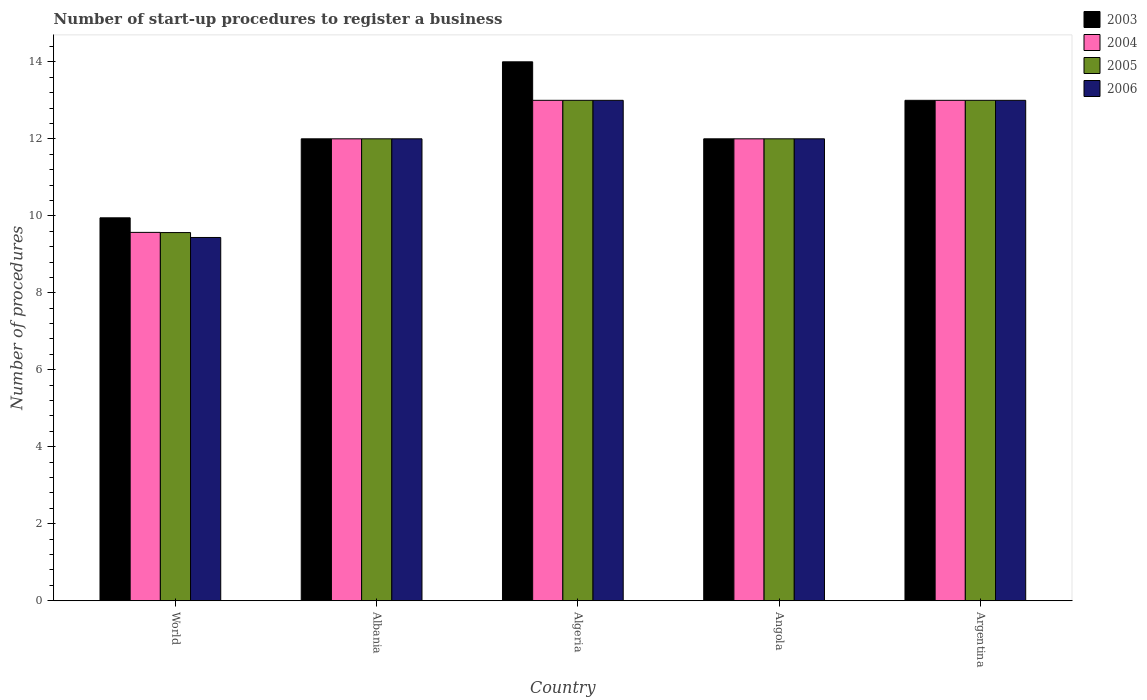What is the label of the 5th group of bars from the left?
Your answer should be compact. Argentina. In how many cases, is the number of bars for a given country not equal to the number of legend labels?
Give a very brief answer. 0. Across all countries, what is the maximum number of procedures required to register a business in 2004?
Offer a terse response. 13. Across all countries, what is the minimum number of procedures required to register a business in 2005?
Keep it short and to the point. 9.56. In which country was the number of procedures required to register a business in 2005 maximum?
Make the answer very short. Algeria. What is the total number of procedures required to register a business in 2003 in the graph?
Give a very brief answer. 60.95. What is the average number of procedures required to register a business in 2005 per country?
Provide a short and direct response. 11.91. What is the ratio of the number of procedures required to register a business in 2005 in Algeria to that in World?
Your answer should be compact. 1.36. Is the number of procedures required to register a business in 2005 in Albania less than that in Algeria?
Your answer should be very brief. Yes. Is the difference between the number of procedures required to register a business in 2006 in Algeria and Angola greater than the difference between the number of procedures required to register a business in 2003 in Algeria and Angola?
Your answer should be compact. No. What is the difference between the highest and the second highest number of procedures required to register a business in 2003?
Ensure brevity in your answer.  -1. What is the difference between the highest and the lowest number of procedures required to register a business in 2004?
Your answer should be compact. 3.43. In how many countries, is the number of procedures required to register a business in 2006 greater than the average number of procedures required to register a business in 2006 taken over all countries?
Offer a terse response. 4. What does the 3rd bar from the left in World represents?
Provide a succinct answer. 2005. What does the 4th bar from the right in Albania represents?
Give a very brief answer. 2003. Are all the bars in the graph horizontal?
Your answer should be compact. No. How many countries are there in the graph?
Your answer should be compact. 5. Are the values on the major ticks of Y-axis written in scientific E-notation?
Offer a very short reply. No. Where does the legend appear in the graph?
Ensure brevity in your answer.  Top right. What is the title of the graph?
Offer a very short reply. Number of start-up procedures to register a business. What is the label or title of the X-axis?
Offer a terse response. Country. What is the label or title of the Y-axis?
Make the answer very short. Number of procedures. What is the Number of procedures of 2003 in World?
Offer a terse response. 9.95. What is the Number of procedures in 2004 in World?
Offer a terse response. 9.57. What is the Number of procedures of 2005 in World?
Provide a succinct answer. 9.56. What is the Number of procedures in 2006 in World?
Give a very brief answer. 9.44. What is the Number of procedures of 2005 in Albania?
Your answer should be very brief. 12. What is the Number of procedures of 2005 in Algeria?
Provide a succinct answer. 13. What is the Number of procedures in 2003 in Angola?
Keep it short and to the point. 12. What is the Number of procedures of 2004 in Angola?
Give a very brief answer. 12. What is the Number of procedures of 2004 in Argentina?
Your answer should be compact. 13. Across all countries, what is the maximum Number of procedures in 2005?
Give a very brief answer. 13. Across all countries, what is the minimum Number of procedures of 2003?
Make the answer very short. 9.95. Across all countries, what is the minimum Number of procedures in 2004?
Your answer should be compact. 9.57. Across all countries, what is the minimum Number of procedures in 2005?
Ensure brevity in your answer.  9.56. Across all countries, what is the minimum Number of procedures in 2006?
Provide a short and direct response. 9.44. What is the total Number of procedures in 2003 in the graph?
Your response must be concise. 60.95. What is the total Number of procedures of 2004 in the graph?
Your answer should be very brief. 59.57. What is the total Number of procedures of 2005 in the graph?
Keep it short and to the point. 59.56. What is the total Number of procedures of 2006 in the graph?
Offer a terse response. 59.44. What is the difference between the Number of procedures of 2003 in World and that in Albania?
Offer a very short reply. -2.05. What is the difference between the Number of procedures of 2004 in World and that in Albania?
Provide a short and direct response. -2.43. What is the difference between the Number of procedures of 2005 in World and that in Albania?
Ensure brevity in your answer.  -2.44. What is the difference between the Number of procedures in 2006 in World and that in Albania?
Your answer should be very brief. -2.56. What is the difference between the Number of procedures of 2003 in World and that in Algeria?
Ensure brevity in your answer.  -4.05. What is the difference between the Number of procedures in 2004 in World and that in Algeria?
Make the answer very short. -3.43. What is the difference between the Number of procedures of 2005 in World and that in Algeria?
Ensure brevity in your answer.  -3.44. What is the difference between the Number of procedures in 2006 in World and that in Algeria?
Keep it short and to the point. -3.56. What is the difference between the Number of procedures in 2003 in World and that in Angola?
Provide a short and direct response. -2.05. What is the difference between the Number of procedures in 2004 in World and that in Angola?
Give a very brief answer. -2.43. What is the difference between the Number of procedures of 2005 in World and that in Angola?
Your response must be concise. -2.44. What is the difference between the Number of procedures of 2006 in World and that in Angola?
Your answer should be compact. -2.56. What is the difference between the Number of procedures of 2003 in World and that in Argentina?
Your answer should be very brief. -3.05. What is the difference between the Number of procedures in 2004 in World and that in Argentina?
Provide a succinct answer. -3.43. What is the difference between the Number of procedures of 2005 in World and that in Argentina?
Your answer should be compact. -3.44. What is the difference between the Number of procedures in 2006 in World and that in Argentina?
Your answer should be compact. -3.56. What is the difference between the Number of procedures of 2005 in Albania and that in Algeria?
Your answer should be very brief. -1. What is the difference between the Number of procedures of 2003 in Albania and that in Angola?
Offer a terse response. 0. What is the difference between the Number of procedures in 2004 in Albania and that in Angola?
Provide a succinct answer. 0. What is the difference between the Number of procedures in 2006 in Albania and that in Angola?
Your answer should be very brief. 0. What is the difference between the Number of procedures in 2004 in Algeria and that in Angola?
Your answer should be very brief. 1. What is the difference between the Number of procedures in 2004 in Algeria and that in Argentina?
Offer a very short reply. 0. What is the difference between the Number of procedures in 2005 in Algeria and that in Argentina?
Provide a short and direct response. 0. What is the difference between the Number of procedures in 2003 in Angola and that in Argentina?
Offer a very short reply. -1. What is the difference between the Number of procedures of 2006 in Angola and that in Argentina?
Provide a succinct answer. -1. What is the difference between the Number of procedures in 2003 in World and the Number of procedures in 2004 in Albania?
Provide a succinct answer. -2.05. What is the difference between the Number of procedures of 2003 in World and the Number of procedures of 2005 in Albania?
Offer a terse response. -2.05. What is the difference between the Number of procedures of 2003 in World and the Number of procedures of 2006 in Albania?
Keep it short and to the point. -2.05. What is the difference between the Number of procedures in 2004 in World and the Number of procedures in 2005 in Albania?
Your answer should be very brief. -2.43. What is the difference between the Number of procedures of 2004 in World and the Number of procedures of 2006 in Albania?
Offer a terse response. -2.43. What is the difference between the Number of procedures of 2005 in World and the Number of procedures of 2006 in Albania?
Give a very brief answer. -2.44. What is the difference between the Number of procedures of 2003 in World and the Number of procedures of 2004 in Algeria?
Provide a succinct answer. -3.05. What is the difference between the Number of procedures in 2003 in World and the Number of procedures in 2005 in Algeria?
Provide a short and direct response. -3.05. What is the difference between the Number of procedures of 2003 in World and the Number of procedures of 2006 in Algeria?
Your answer should be compact. -3.05. What is the difference between the Number of procedures in 2004 in World and the Number of procedures in 2005 in Algeria?
Your answer should be compact. -3.43. What is the difference between the Number of procedures in 2004 in World and the Number of procedures in 2006 in Algeria?
Your response must be concise. -3.43. What is the difference between the Number of procedures in 2005 in World and the Number of procedures in 2006 in Algeria?
Make the answer very short. -3.44. What is the difference between the Number of procedures of 2003 in World and the Number of procedures of 2004 in Angola?
Ensure brevity in your answer.  -2.05. What is the difference between the Number of procedures of 2003 in World and the Number of procedures of 2005 in Angola?
Give a very brief answer. -2.05. What is the difference between the Number of procedures in 2003 in World and the Number of procedures in 2006 in Angola?
Keep it short and to the point. -2.05. What is the difference between the Number of procedures of 2004 in World and the Number of procedures of 2005 in Angola?
Ensure brevity in your answer.  -2.43. What is the difference between the Number of procedures of 2004 in World and the Number of procedures of 2006 in Angola?
Keep it short and to the point. -2.43. What is the difference between the Number of procedures of 2005 in World and the Number of procedures of 2006 in Angola?
Offer a terse response. -2.44. What is the difference between the Number of procedures of 2003 in World and the Number of procedures of 2004 in Argentina?
Give a very brief answer. -3.05. What is the difference between the Number of procedures in 2003 in World and the Number of procedures in 2005 in Argentina?
Offer a very short reply. -3.05. What is the difference between the Number of procedures of 2003 in World and the Number of procedures of 2006 in Argentina?
Offer a very short reply. -3.05. What is the difference between the Number of procedures of 2004 in World and the Number of procedures of 2005 in Argentina?
Give a very brief answer. -3.43. What is the difference between the Number of procedures of 2004 in World and the Number of procedures of 2006 in Argentina?
Give a very brief answer. -3.43. What is the difference between the Number of procedures in 2005 in World and the Number of procedures in 2006 in Argentina?
Make the answer very short. -3.44. What is the difference between the Number of procedures of 2003 in Albania and the Number of procedures of 2005 in Algeria?
Your answer should be very brief. -1. What is the difference between the Number of procedures in 2004 in Albania and the Number of procedures in 2005 in Algeria?
Ensure brevity in your answer.  -1. What is the difference between the Number of procedures of 2004 in Albania and the Number of procedures of 2006 in Algeria?
Your answer should be compact. -1. What is the difference between the Number of procedures in 2005 in Albania and the Number of procedures in 2006 in Algeria?
Ensure brevity in your answer.  -1. What is the difference between the Number of procedures in 2003 in Albania and the Number of procedures in 2004 in Angola?
Your answer should be very brief. 0. What is the difference between the Number of procedures in 2004 in Albania and the Number of procedures in 2006 in Angola?
Ensure brevity in your answer.  0. What is the difference between the Number of procedures of 2003 in Albania and the Number of procedures of 2005 in Argentina?
Your answer should be very brief. -1. What is the difference between the Number of procedures of 2003 in Algeria and the Number of procedures of 2004 in Angola?
Provide a succinct answer. 2. What is the difference between the Number of procedures of 2003 in Algeria and the Number of procedures of 2006 in Angola?
Offer a terse response. 2. What is the difference between the Number of procedures in 2004 in Algeria and the Number of procedures in 2005 in Angola?
Ensure brevity in your answer.  1. What is the difference between the Number of procedures in 2004 in Algeria and the Number of procedures in 2005 in Argentina?
Offer a terse response. 0. What is the difference between the Number of procedures of 2004 in Algeria and the Number of procedures of 2006 in Argentina?
Offer a very short reply. 0. What is the difference between the Number of procedures of 2005 in Algeria and the Number of procedures of 2006 in Argentina?
Give a very brief answer. 0. What is the difference between the Number of procedures of 2003 in Angola and the Number of procedures of 2005 in Argentina?
Give a very brief answer. -1. What is the difference between the Number of procedures of 2003 in Angola and the Number of procedures of 2006 in Argentina?
Your response must be concise. -1. What is the difference between the Number of procedures of 2004 in Angola and the Number of procedures of 2006 in Argentina?
Your answer should be compact. -1. What is the difference between the Number of procedures of 2005 in Angola and the Number of procedures of 2006 in Argentina?
Provide a short and direct response. -1. What is the average Number of procedures in 2003 per country?
Your answer should be compact. 12.19. What is the average Number of procedures in 2004 per country?
Keep it short and to the point. 11.91. What is the average Number of procedures of 2005 per country?
Provide a succinct answer. 11.91. What is the average Number of procedures of 2006 per country?
Offer a very short reply. 11.89. What is the difference between the Number of procedures in 2003 and Number of procedures in 2004 in World?
Keep it short and to the point. 0.38. What is the difference between the Number of procedures of 2003 and Number of procedures of 2005 in World?
Provide a short and direct response. 0.38. What is the difference between the Number of procedures in 2003 and Number of procedures in 2006 in World?
Make the answer very short. 0.51. What is the difference between the Number of procedures in 2004 and Number of procedures in 2005 in World?
Your response must be concise. 0.01. What is the difference between the Number of procedures of 2004 and Number of procedures of 2006 in World?
Make the answer very short. 0.13. What is the difference between the Number of procedures in 2005 and Number of procedures in 2006 in World?
Give a very brief answer. 0.13. What is the difference between the Number of procedures of 2004 and Number of procedures of 2005 in Albania?
Your response must be concise. 0. What is the difference between the Number of procedures in 2004 and Number of procedures in 2006 in Albania?
Your answer should be very brief. 0. What is the difference between the Number of procedures of 2005 and Number of procedures of 2006 in Albania?
Your answer should be very brief. 0. What is the difference between the Number of procedures of 2003 and Number of procedures of 2005 in Algeria?
Give a very brief answer. 1. What is the difference between the Number of procedures in 2004 and Number of procedures in 2006 in Algeria?
Offer a very short reply. 0. What is the difference between the Number of procedures in 2003 and Number of procedures in 2005 in Angola?
Provide a short and direct response. 0. What is the difference between the Number of procedures of 2004 and Number of procedures of 2006 in Angola?
Your response must be concise. 0. What is the difference between the Number of procedures in 2003 and Number of procedures in 2004 in Argentina?
Give a very brief answer. 0. What is the difference between the Number of procedures in 2003 and Number of procedures in 2005 in Argentina?
Keep it short and to the point. 0. What is the difference between the Number of procedures in 2003 and Number of procedures in 2006 in Argentina?
Your answer should be compact. 0. What is the difference between the Number of procedures of 2004 and Number of procedures of 2005 in Argentina?
Keep it short and to the point. 0. What is the difference between the Number of procedures of 2005 and Number of procedures of 2006 in Argentina?
Keep it short and to the point. 0. What is the ratio of the Number of procedures in 2003 in World to that in Albania?
Your response must be concise. 0.83. What is the ratio of the Number of procedures in 2004 in World to that in Albania?
Make the answer very short. 0.8. What is the ratio of the Number of procedures of 2005 in World to that in Albania?
Provide a succinct answer. 0.8. What is the ratio of the Number of procedures in 2006 in World to that in Albania?
Your answer should be compact. 0.79. What is the ratio of the Number of procedures in 2003 in World to that in Algeria?
Your response must be concise. 0.71. What is the ratio of the Number of procedures in 2004 in World to that in Algeria?
Offer a terse response. 0.74. What is the ratio of the Number of procedures of 2005 in World to that in Algeria?
Give a very brief answer. 0.74. What is the ratio of the Number of procedures in 2006 in World to that in Algeria?
Your answer should be very brief. 0.73. What is the ratio of the Number of procedures of 2003 in World to that in Angola?
Offer a terse response. 0.83. What is the ratio of the Number of procedures of 2004 in World to that in Angola?
Make the answer very short. 0.8. What is the ratio of the Number of procedures in 2005 in World to that in Angola?
Keep it short and to the point. 0.8. What is the ratio of the Number of procedures of 2006 in World to that in Angola?
Provide a succinct answer. 0.79. What is the ratio of the Number of procedures in 2003 in World to that in Argentina?
Provide a short and direct response. 0.77. What is the ratio of the Number of procedures of 2004 in World to that in Argentina?
Your answer should be very brief. 0.74. What is the ratio of the Number of procedures of 2005 in World to that in Argentina?
Keep it short and to the point. 0.74. What is the ratio of the Number of procedures in 2006 in World to that in Argentina?
Make the answer very short. 0.73. What is the ratio of the Number of procedures in 2004 in Albania to that in Algeria?
Give a very brief answer. 0.92. What is the ratio of the Number of procedures in 2005 in Albania to that in Algeria?
Provide a short and direct response. 0.92. What is the ratio of the Number of procedures of 2006 in Albania to that in Algeria?
Your answer should be compact. 0.92. What is the ratio of the Number of procedures in 2004 in Albania to that in Angola?
Your response must be concise. 1. What is the ratio of the Number of procedures of 2005 in Albania to that in Argentina?
Provide a short and direct response. 0.92. What is the ratio of the Number of procedures of 2006 in Albania to that in Argentina?
Give a very brief answer. 0.92. What is the ratio of the Number of procedures of 2003 in Algeria to that in Angola?
Give a very brief answer. 1.17. What is the ratio of the Number of procedures of 2004 in Algeria to that in Angola?
Make the answer very short. 1.08. What is the ratio of the Number of procedures of 2004 in Algeria to that in Argentina?
Ensure brevity in your answer.  1. What is the ratio of the Number of procedures in 2005 in Algeria to that in Argentina?
Your answer should be very brief. 1. What is the ratio of the Number of procedures of 2006 in Algeria to that in Argentina?
Ensure brevity in your answer.  1. What is the ratio of the Number of procedures of 2004 in Angola to that in Argentina?
Offer a very short reply. 0.92. What is the difference between the highest and the second highest Number of procedures of 2006?
Make the answer very short. 0. What is the difference between the highest and the lowest Number of procedures of 2003?
Keep it short and to the point. 4.05. What is the difference between the highest and the lowest Number of procedures of 2004?
Give a very brief answer. 3.43. What is the difference between the highest and the lowest Number of procedures in 2005?
Your answer should be compact. 3.44. What is the difference between the highest and the lowest Number of procedures of 2006?
Keep it short and to the point. 3.56. 